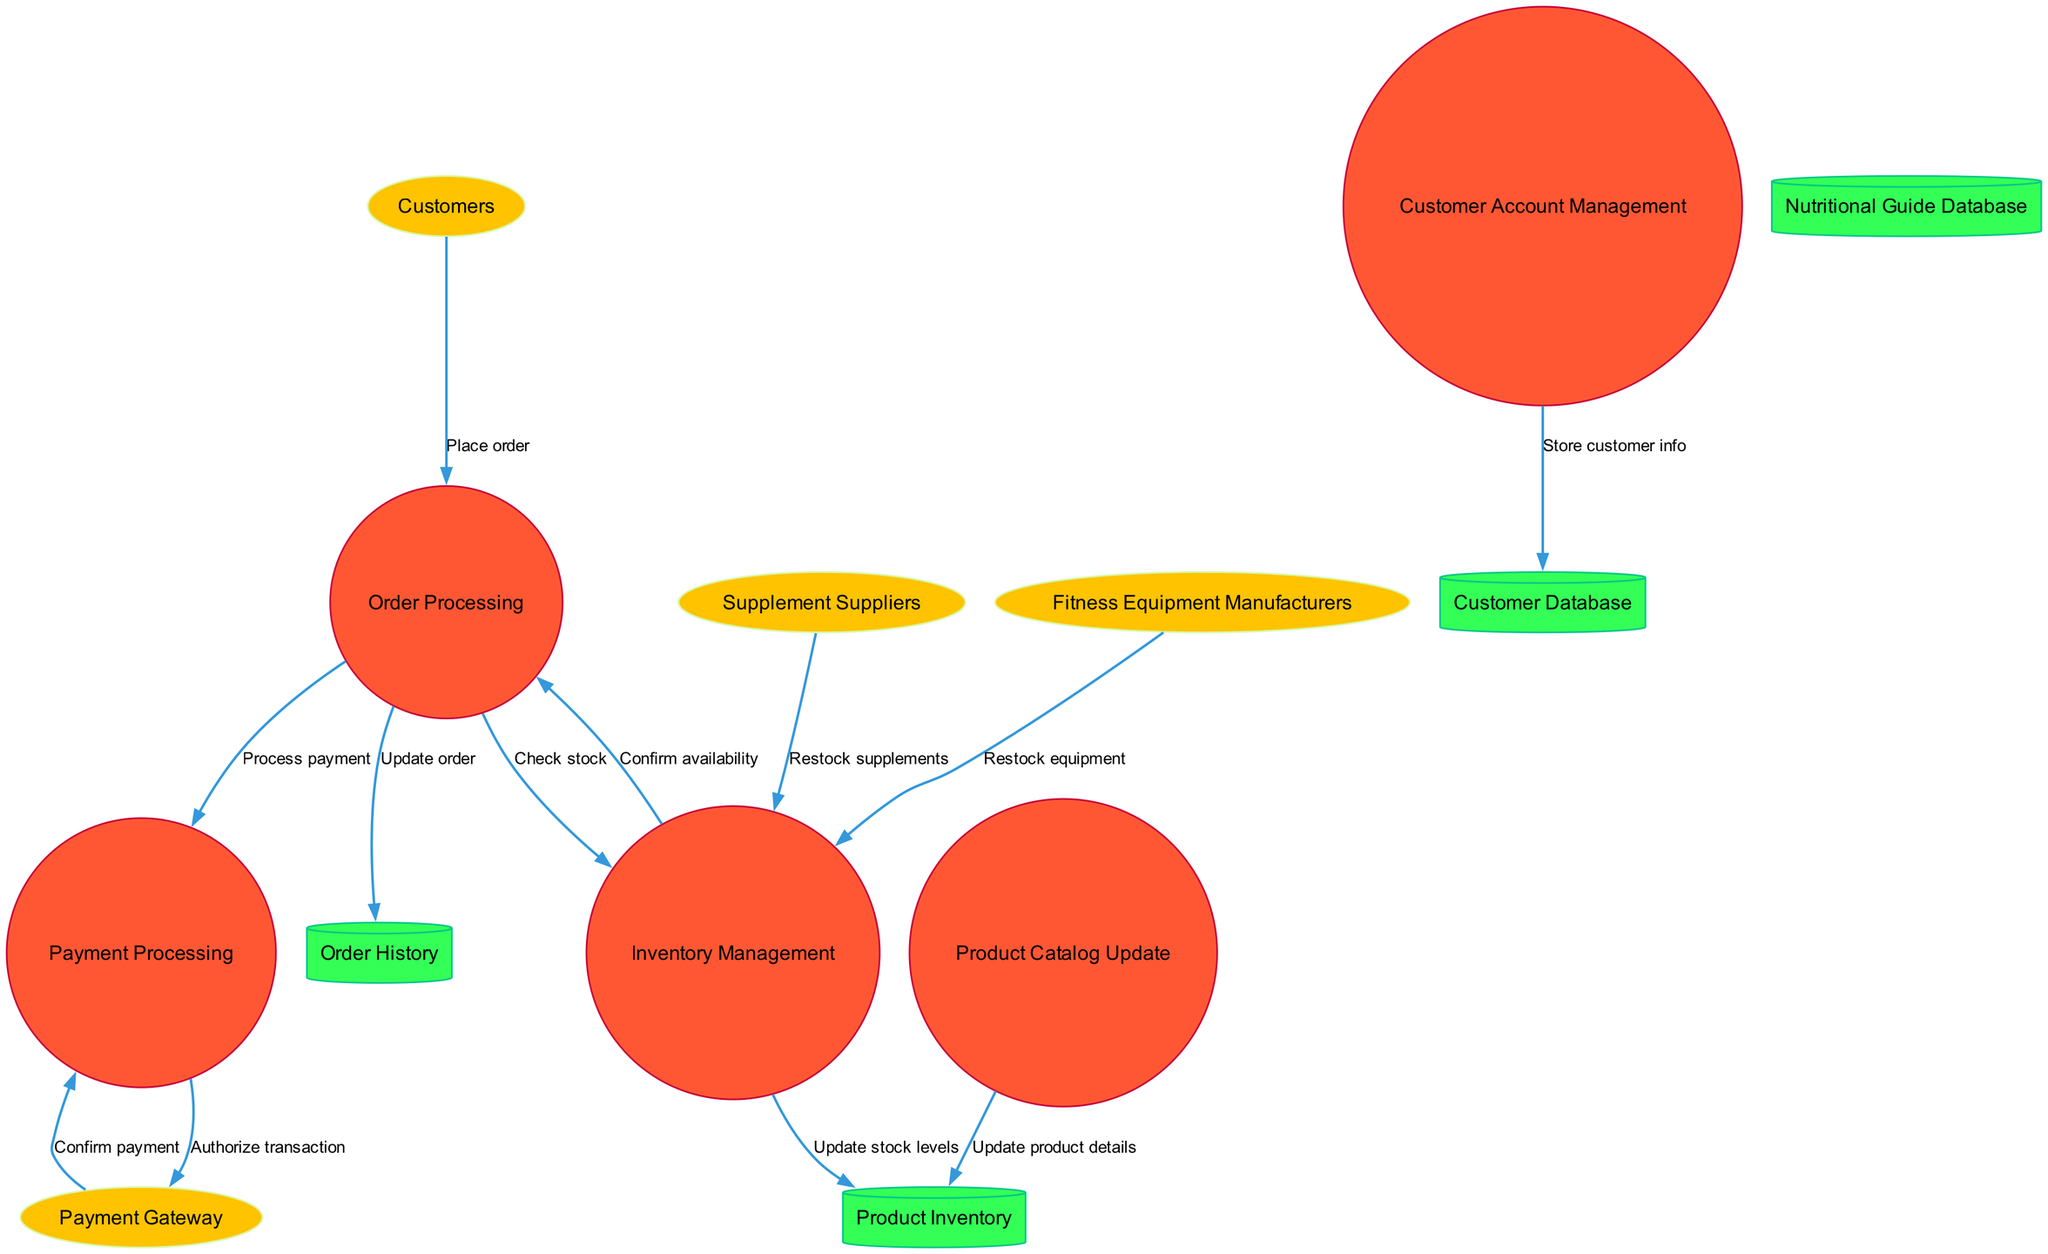How many external entities are present in the diagram? The diagram includes four external entities: Customers, Supplement Suppliers, Fitness Equipment Manufacturers, and Payment Gateway.
Answer: Four What process handles the payment transactions? The Payment Processing process is responsible for handling payment transactions as indicated in the flow from Order Processing to Payment Processing.
Answer: Payment Processing Which external entity restocks fitness equipment? The Fitness Equipment Manufacturers external entity is the one that restocks fitness equipment, as shown in the flow to Inventory Management.
Answer: Fitness Equipment Manufacturers What data store is updated to keep track of customer information? The Customer Database data store is updated by the Customer Account Management process to store customer information.
Answer: Customer Database What is the first step when a customer places an order? The first step is the Place order flow from Customers to Order Processing, which indicates that the Order Processing process is initiated by the customer placing an order.
Answer: Order Processing What happens after the payment is confirmed? After payment is confirmed, the flow goes from Payment Processing to Order History to update the order, indicating that the order status is updated once the payment is processed successfully.
Answer: Update order How many processes are involved in the diagram? The diagram includes five processes: Order Processing, Inventory Management, Customer Account Management, Product Catalog Update, and Payment Processing.
Answer: Five Which process checks stock availability? The Inventory Management process checks stock availability as evidenced by the flow from Order Processing to Inventory Management labeled "Check stock."
Answer: Inventory Management What type of data does the Nutritional Guide Database store? The diagram does not explicitly state what specific data the Nutritional Guide Database stores, but it implies that it's related to nutrition, likely containing relevant nutritional information.
Answer: Nutritional information 